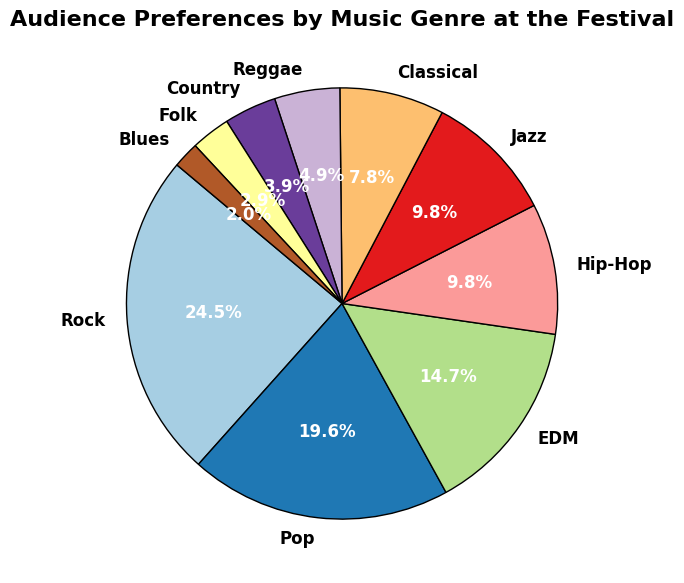What's the most popular music genre at the festival? The pie chart shows several music genres with their corresponding percentages. By observing the slices, Rock has the largest slice, indicating it is the most popular.
Answer: Rock Which music genre has the smallest percentage of audience preference? Look for the smallest slice in the pie chart. Blues has the smallest slice, indicating it has the smallest percentage of audience preference.
Answer: Blues What is the combined percentage of the audience that prefers Jazz and Classical music? Summing up the percentages for Jazz (10%) and Classical (8%) gives 10% + 8% = 18%.
Answer: 18% Is the percentage of audience preference for EDM greater than that for Hip-Hop? Compare the sizes of the slices or directly refer to their percentages: EDM is 15% and Hip-Hop is 10%, so EDM is greater.
Answer: Yes What is the difference in audience preferences between the top two genres? The top two genres are Rock (25%) and Pop (20%). Subtracting the percentage for Pop from Rock gives 25% - 20% = 5%.
Answer: 5% How does the audience preference for Reggae compare to Country? Comparing their percentages, Reggae has 5%, and Country has 4%. Reggae is slightly higher.
Answer: Reggae is higher Which genres have an audience preference of less than 5%? Identify the slices with less than 5%: Country (4%), Folk (3%), Blues (2%).
Answer: Country, Folk, Blues By what factor is the audience preference for Pop larger than that for Blues? Divide the percentage for Pop (20%) by the percentage for Blues (2%) to find the factor: 20% / 2% = 10.
Answer: 10 If a similar pie chart was drawn for a festival in a different location and the Classical music preference doubled, what would be the new percentage for Classical? Doubling the current Classical preference (8%) results in 8% * 2 = 16%.
Answer: 16% What percentage of the audience prefers either Rock or EDM? Add the percentages for Rock (25%) and EDM (15%): 25% + 15% = 40%.
Answer: 40% 